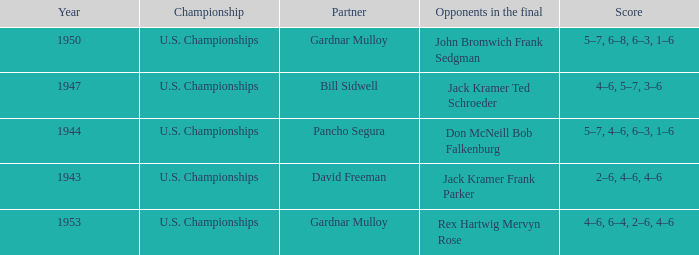Which Score has Opponents in the final of john bromwich frank sedgman? 5–7, 6–8, 6–3, 1–6. Would you be able to parse every entry in this table? {'header': ['Year', 'Championship', 'Partner', 'Opponents in the final', 'Score'], 'rows': [['1950', 'U.S. Championships', 'Gardnar Mulloy', 'John Bromwich Frank Sedgman', '5–7, 6–8, 6–3, 1–6'], ['1947', 'U.S. Championships', 'Bill Sidwell', 'Jack Kramer Ted Schroeder', '4–6, 5–7, 3–6'], ['1944', 'U.S. Championships', 'Pancho Segura', 'Don McNeill Bob Falkenburg', '5–7, 4–6, 6–3, 1–6'], ['1943', 'U.S. Championships', 'David Freeman', 'Jack Kramer Frank Parker', '2–6, 4–6, 4–6'], ['1953', 'U.S. Championships', 'Gardnar Mulloy', 'Rex Hartwig Mervyn Rose', '4–6, 6–4, 2–6, 4–6']]} 